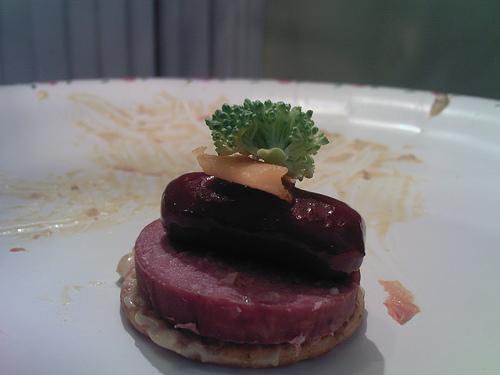How many layers are there?
Give a very brief answer. 5. How many pieces of broccoli are there?
Give a very brief answer. 1. 